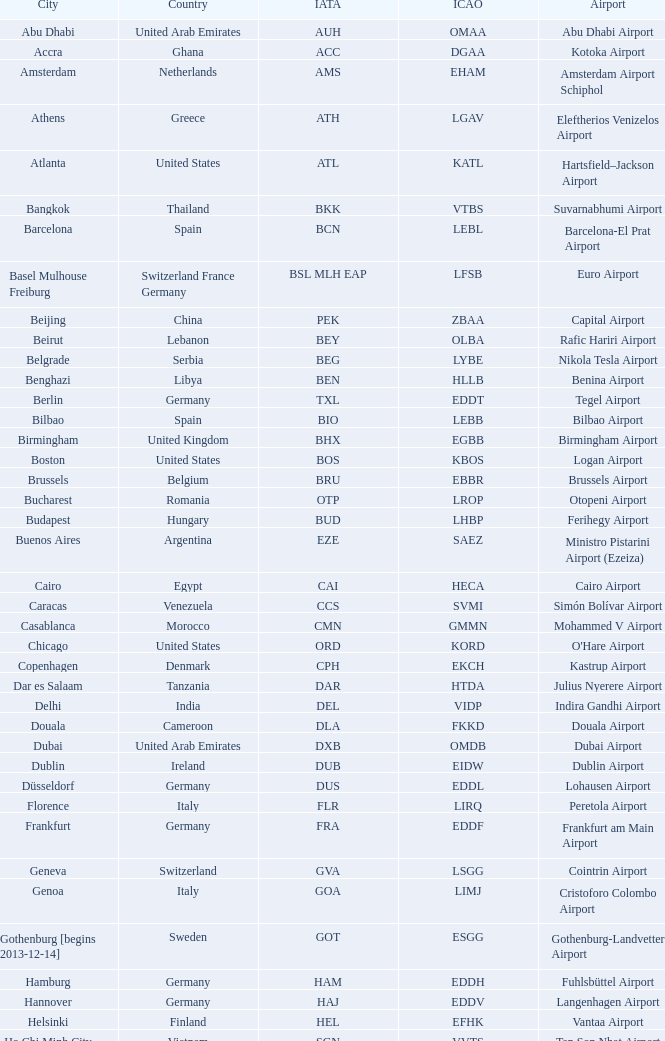What is the IATA for Ringway Airport in the United Kingdom? MAN. 